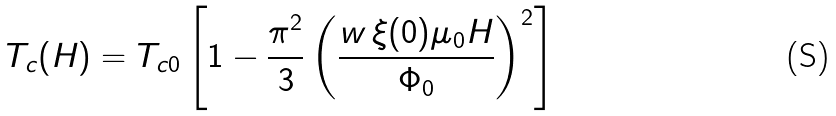<formula> <loc_0><loc_0><loc_500><loc_500>T _ { c } ( H ) = T _ { c 0 } \left [ 1 - \frac { \pi ^ { 2 } } { 3 } \left ( \frac { w \, \xi ( 0 ) \mu _ { 0 } H } { \Phi _ { 0 } } \right ) ^ { 2 } \right ]</formula> 